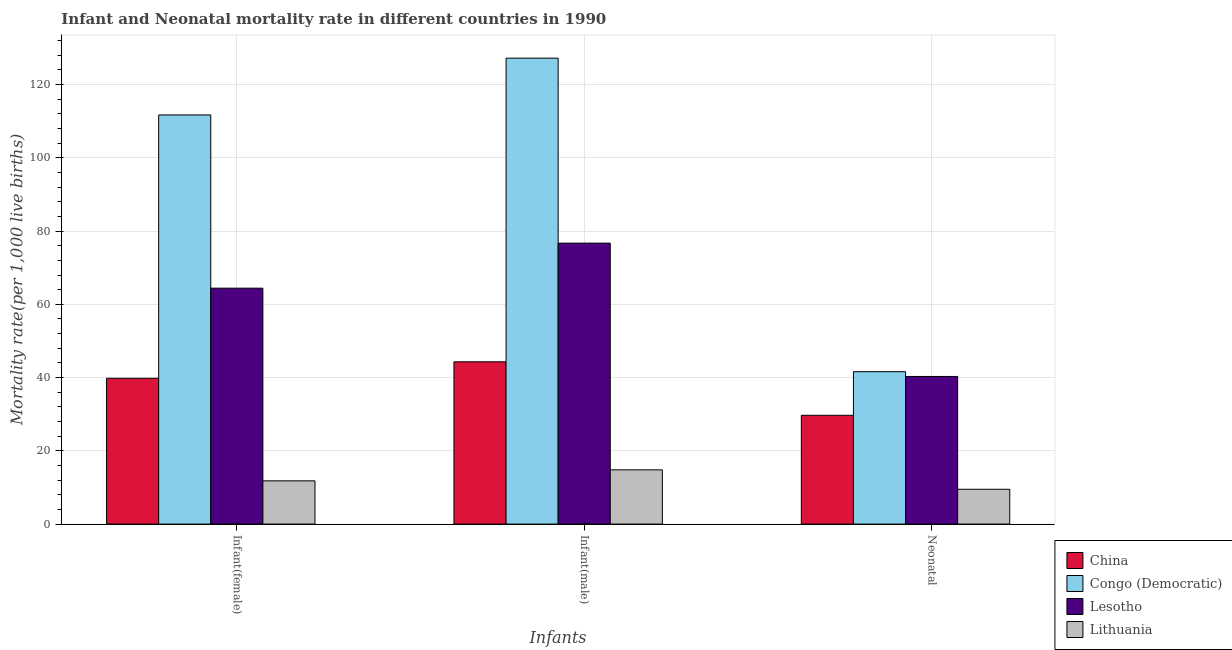How many different coloured bars are there?
Your response must be concise. 4. Are the number of bars per tick equal to the number of legend labels?
Your answer should be very brief. Yes. Are the number of bars on each tick of the X-axis equal?
Your response must be concise. Yes. What is the label of the 1st group of bars from the left?
Make the answer very short. Infant(female). What is the infant mortality rate(male) in Congo (Democratic)?
Ensure brevity in your answer.  127.2. Across all countries, what is the maximum neonatal mortality rate?
Your answer should be very brief. 41.6. In which country was the infant mortality rate(male) maximum?
Your answer should be compact. Congo (Democratic). In which country was the neonatal mortality rate minimum?
Your response must be concise. Lithuania. What is the total infant mortality rate(male) in the graph?
Ensure brevity in your answer.  263. What is the difference between the neonatal mortality rate in China and that in Congo (Democratic)?
Offer a terse response. -11.9. What is the average neonatal mortality rate per country?
Give a very brief answer. 30.27. What is the difference between the infant mortality rate(male) and neonatal mortality rate in China?
Your response must be concise. 14.6. What is the ratio of the infant mortality rate(male) in Lithuania to that in Congo (Democratic)?
Offer a very short reply. 0.12. Is the infant mortality rate(male) in Congo (Democratic) less than that in Lithuania?
Provide a short and direct response. No. What is the difference between the highest and the second highest infant mortality rate(male)?
Make the answer very short. 50.5. What is the difference between the highest and the lowest neonatal mortality rate?
Your answer should be compact. 32.1. In how many countries, is the neonatal mortality rate greater than the average neonatal mortality rate taken over all countries?
Your response must be concise. 2. What does the 1st bar from the right in Infant(female) represents?
Your response must be concise. Lithuania. Is it the case that in every country, the sum of the infant mortality rate(female) and infant mortality rate(male) is greater than the neonatal mortality rate?
Your response must be concise. Yes. Are all the bars in the graph horizontal?
Provide a short and direct response. No. What is the difference between two consecutive major ticks on the Y-axis?
Your answer should be compact. 20. Are the values on the major ticks of Y-axis written in scientific E-notation?
Make the answer very short. No. Does the graph contain any zero values?
Provide a short and direct response. No. Does the graph contain grids?
Make the answer very short. Yes. How are the legend labels stacked?
Offer a very short reply. Vertical. What is the title of the graph?
Offer a terse response. Infant and Neonatal mortality rate in different countries in 1990. Does "Malaysia" appear as one of the legend labels in the graph?
Give a very brief answer. No. What is the label or title of the X-axis?
Make the answer very short. Infants. What is the label or title of the Y-axis?
Make the answer very short. Mortality rate(per 1,0 live births). What is the Mortality rate(per 1,000 live births) of China in Infant(female)?
Provide a succinct answer. 39.8. What is the Mortality rate(per 1,000 live births) of Congo (Democratic) in Infant(female)?
Provide a short and direct response. 111.7. What is the Mortality rate(per 1,000 live births) in Lesotho in Infant(female)?
Ensure brevity in your answer.  64.4. What is the Mortality rate(per 1,000 live births) in Lithuania in Infant(female)?
Ensure brevity in your answer.  11.8. What is the Mortality rate(per 1,000 live births) of China in Infant(male)?
Offer a terse response. 44.3. What is the Mortality rate(per 1,000 live births) in Congo (Democratic) in Infant(male)?
Provide a succinct answer. 127.2. What is the Mortality rate(per 1,000 live births) in Lesotho in Infant(male)?
Offer a terse response. 76.7. What is the Mortality rate(per 1,000 live births) of Lithuania in Infant(male)?
Ensure brevity in your answer.  14.8. What is the Mortality rate(per 1,000 live births) of China in Neonatal ?
Your response must be concise. 29.7. What is the Mortality rate(per 1,000 live births) in Congo (Democratic) in Neonatal ?
Provide a succinct answer. 41.6. What is the Mortality rate(per 1,000 live births) in Lesotho in Neonatal ?
Keep it short and to the point. 40.3. What is the Mortality rate(per 1,000 live births) in Lithuania in Neonatal ?
Give a very brief answer. 9.5. Across all Infants, what is the maximum Mortality rate(per 1,000 live births) in China?
Ensure brevity in your answer.  44.3. Across all Infants, what is the maximum Mortality rate(per 1,000 live births) of Congo (Democratic)?
Your response must be concise. 127.2. Across all Infants, what is the maximum Mortality rate(per 1,000 live births) in Lesotho?
Offer a very short reply. 76.7. Across all Infants, what is the minimum Mortality rate(per 1,000 live births) in China?
Ensure brevity in your answer.  29.7. Across all Infants, what is the minimum Mortality rate(per 1,000 live births) of Congo (Democratic)?
Ensure brevity in your answer.  41.6. Across all Infants, what is the minimum Mortality rate(per 1,000 live births) in Lesotho?
Your response must be concise. 40.3. Across all Infants, what is the minimum Mortality rate(per 1,000 live births) of Lithuania?
Your response must be concise. 9.5. What is the total Mortality rate(per 1,000 live births) in China in the graph?
Give a very brief answer. 113.8. What is the total Mortality rate(per 1,000 live births) in Congo (Democratic) in the graph?
Provide a succinct answer. 280.5. What is the total Mortality rate(per 1,000 live births) in Lesotho in the graph?
Provide a short and direct response. 181.4. What is the total Mortality rate(per 1,000 live births) of Lithuania in the graph?
Give a very brief answer. 36.1. What is the difference between the Mortality rate(per 1,000 live births) of China in Infant(female) and that in Infant(male)?
Ensure brevity in your answer.  -4.5. What is the difference between the Mortality rate(per 1,000 live births) of Congo (Democratic) in Infant(female) and that in Infant(male)?
Offer a very short reply. -15.5. What is the difference between the Mortality rate(per 1,000 live births) in Lesotho in Infant(female) and that in Infant(male)?
Keep it short and to the point. -12.3. What is the difference between the Mortality rate(per 1,000 live births) of Congo (Democratic) in Infant(female) and that in Neonatal ?
Offer a very short reply. 70.1. What is the difference between the Mortality rate(per 1,000 live births) in Lesotho in Infant(female) and that in Neonatal ?
Your answer should be compact. 24.1. What is the difference between the Mortality rate(per 1,000 live births) of Lithuania in Infant(female) and that in Neonatal ?
Your response must be concise. 2.3. What is the difference between the Mortality rate(per 1,000 live births) in Congo (Democratic) in Infant(male) and that in Neonatal ?
Keep it short and to the point. 85.6. What is the difference between the Mortality rate(per 1,000 live births) of Lesotho in Infant(male) and that in Neonatal ?
Provide a succinct answer. 36.4. What is the difference between the Mortality rate(per 1,000 live births) of China in Infant(female) and the Mortality rate(per 1,000 live births) of Congo (Democratic) in Infant(male)?
Provide a short and direct response. -87.4. What is the difference between the Mortality rate(per 1,000 live births) in China in Infant(female) and the Mortality rate(per 1,000 live births) in Lesotho in Infant(male)?
Offer a very short reply. -36.9. What is the difference between the Mortality rate(per 1,000 live births) in Congo (Democratic) in Infant(female) and the Mortality rate(per 1,000 live births) in Lesotho in Infant(male)?
Provide a succinct answer. 35. What is the difference between the Mortality rate(per 1,000 live births) of Congo (Democratic) in Infant(female) and the Mortality rate(per 1,000 live births) of Lithuania in Infant(male)?
Make the answer very short. 96.9. What is the difference between the Mortality rate(per 1,000 live births) of Lesotho in Infant(female) and the Mortality rate(per 1,000 live births) of Lithuania in Infant(male)?
Offer a terse response. 49.6. What is the difference between the Mortality rate(per 1,000 live births) of China in Infant(female) and the Mortality rate(per 1,000 live births) of Congo (Democratic) in Neonatal?
Provide a short and direct response. -1.8. What is the difference between the Mortality rate(per 1,000 live births) of China in Infant(female) and the Mortality rate(per 1,000 live births) of Lithuania in Neonatal?
Offer a terse response. 30.3. What is the difference between the Mortality rate(per 1,000 live births) of Congo (Democratic) in Infant(female) and the Mortality rate(per 1,000 live births) of Lesotho in Neonatal?
Your response must be concise. 71.4. What is the difference between the Mortality rate(per 1,000 live births) in Congo (Democratic) in Infant(female) and the Mortality rate(per 1,000 live births) in Lithuania in Neonatal?
Your response must be concise. 102.2. What is the difference between the Mortality rate(per 1,000 live births) in Lesotho in Infant(female) and the Mortality rate(per 1,000 live births) in Lithuania in Neonatal?
Offer a very short reply. 54.9. What is the difference between the Mortality rate(per 1,000 live births) of China in Infant(male) and the Mortality rate(per 1,000 live births) of Congo (Democratic) in Neonatal?
Offer a terse response. 2.7. What is the difference between the Mortality rate(per 1,000 live births) in China in Infant(male) and the Mortality rate(per 1,000 live births) in Lithuania in Neonatal?
Your response must be concise. 34.8. What is the difference between the Mortality rate(per 1,000 live births) of Congo (Democratic) in Infant(male) and the Mortality rate(per 1,000 live births) of Lesotho in Neonatal?
Ensure brevity in your answer.  86.9. What is the difference between the Mortality rate(per 1,000 live births) in Congo (Democratic) in Infant(male) and the Mortality rate(per 1,000 live births) in Lithuania in Neonatal?
Keep it short and to the point. 117.7. What is the difference between the Mortality rate(per 1,000 live births) in Lesotho in Infant(male) and the Mortality rate(per 1,000 live births) in Lithuania in Neonatal?
Give a very brief answer. 67.2. What is the average Mortality rate(per 1,000 live births) in China per Infants?
Your answer should be compact. 37.93. What is the average Mortality rate(per 1,000 live births) in Congo (Democratic) per Infants?
Keep it short and to the point. 93.5. What is the average Mortality rate(per 1,000 live births) in Lesotho per Infants?
Provide a short and direct response. 60.47. What is the average Mortality rate(per 1,000 live births) of Lithuania per Infants?
Offer a terse response. 12.03. What is the difference between the Mortality rate(per 1,000 live births) in China and Mortality rate(per 1,000 live births) in Congo (Democratic) in Infant(female)?
Your answer should be compact. -71.9. What is the difference between the Mortality rate(per 1,000 live births) of China and Mortality rate(per 1,000 live births) of Lesotho in Infant(female)?
Provide a succinct answer. -24.6. What is the difference between the Mortality rate(per 1,000 live births) in Congo (Democratic) and Mortality rate(per 1,000 live births) in Lesotho in Infant(female)?
Give a very brief answer. 47.3. What is the difference between the Mortality rate(per 1,000 live births) of Congo (Democratic) and Mortality rate(per 1,000 live births) of Lithuania in Infant(female)?
Ensure brevity in your answer.  99.9. What is the difference between the Mortality rate(per 1,000 live births) of Lesotho and Mortality rate(per 1,000 live births) of Lithuania in Infant(female)?
Keep it short and to the point. 52.6. What is the difference between the Mortality rate(per 1,000 live births) in China and Mortality rate(per 1,000 live births) in Congo (Democratic) in Infant(male)?
Keep it short and to the point. -82.9. What is the difference between the Mortality rate(per 1,000 live births) of China and Mortality rate(per 1,000 live births) of Lesotho in Infant(male)?
Provide a succinct answer. -32.4. What is the difference between the Mortality rate(per 1,000 live births) in China and Mortality rate(per 1,000 live births) in Lithuania in Infant(male)?
Your answer should be very brief. 29.5. What is the difference between the Mortality rate(per 1,000 live births) of Congo (Democratic) and Mortality rate(per 1,000 live births) of Lesotho in Infant(male)?
Give a very brief answer. 50.5. What is the difference between the Mortality rate(per 1,000 live births) of Congo (Democratic) and Mortality rate(per 1,000 live births) of Lithuania in Infant(male)?
Make the answer very short. 112.4. What is the difference between the Mortality rate(per 1,000 live births) of Lesotho and Mortality rate(per 1,000 live births) of Lithuania in Infant(male)?
Keep it short and to the point. 61.9. What is the difference between the Mortality rate(per 1,000 live births) in China and Mortality rate(per 1,000 live births) in Congo (Democratic) in Neonatal ?
Offer a very short reply. -11.9. What is the difference between the Mortality rate(per 1,000 live births) of China and Mortality rate(per 1,000 live births) of Lithuania in Neonatal ?
Provide a succinct answer. 20.2. What is the difference between the Mortality rate(per 1,000 live births) in Congo (Democratic) and Mortality rate(per 1,000 live births) in Lesotho in Neonatal ?
Keep it short and to the point. 1.3. What is the difference between the Mortality rate(per 1,000 live births) in Congo (Democratic) and Mortality rate(per 1,000 live births) in Lithuania in Neonatal ?
Your answer should be compact. 32.1. What is the difference between the Mortality rate(per 1,000 live births) in Lesotho and Mortality rate(per 1,000 live births) in Lithuania in Neonatal ?
Provide a short and direct response. 30.8. What is the ratio of the Mortality rate(per 1,000 live births) in China in Infant(female) to that in Infant(male)?
Give a very brief answer. 0.9. What is the ratio of the Mortality rate(per 1,000 live births) of Congo (Democratic) in Infant(female) to that in Infant(male)?
Ensure brevity in your answer.  0.88. What is the ratio of the Mortality rate(per 1,000 live births) in Lesotho in Infant(female) to that in Infant(male)?
Give a very brief answer. 0.84. What is the ratio of the Mortality rate(per 1,000 live births) of Lithuania in Infant(female) to that in Infant(male)?
Your answer should be very brief. 0.8. What is the ratio of the Mortality rate(per 1,000 live births) in China in Infant(female) to that in Neonatal ?
Ensure brevity in your answer.  1.34. What is the ratio of the Mortality rate(per 1,000 live births) of Congo (Democratic) in Infant(female) to that in Neonatal ?
Give a very brief answer. 2.69. What is the ratio of the Mortality rate(per 1,000 live births) in Lesotho in Infant(female) to that in Neonatal ?
Provide a succinct answer. 1.6. What is the ratio of the Mortality rate(per 1,000 live births) of Lithuania in Infant(female) to that in Neonatal ?
Keep it short and to the point. 1.24. What is the ratio of the Mortality rate(per 1,000 live births) in China in Infant(male) to that in Neonatal ?
Make the answer very short. 1.49. What is the ratio of the Mortality rate(per 1,000 live births) in Congo (Democratic) in Infant(male) to that in Neonatal ?
Make the answer very short. 3.06. What is the ratio of the Mortality rate(per 1,000 live births) in Lesotho in Infant(male) to that in Neonatal ?
Your answer should be very brief. 1.9. What is the ratio of the Mortality rate(per 1,000 live births) in Lithuania in Infant(male) to that in Neonatal ?
Ensure brevity in your answer.  1.56. What is the difference between the highest and the second highest Mortality rate(per 1,000 live births) in Congo (Democratic)?
Give a very brief answer. 15.5. What is the difference between the highest and the second highest Mortality rate(per 1,000 live births) in Lithuania?
Give a very brief answer. 3. What is the difference between the highest and the lowest Mortality rate(per 1,000 live births) of China?
Give a very brief answer. 14.6. What is the difference between the highest and the lowest Mortality rate(per 1,000 live births) of Congo (Democratic)?
Give a very brief answer. 85.6. What is the difference between the highest and the lowest Mortality rate(per 1,000 live births) in Lesotho?
Provide a short and direct response. 36.4. 